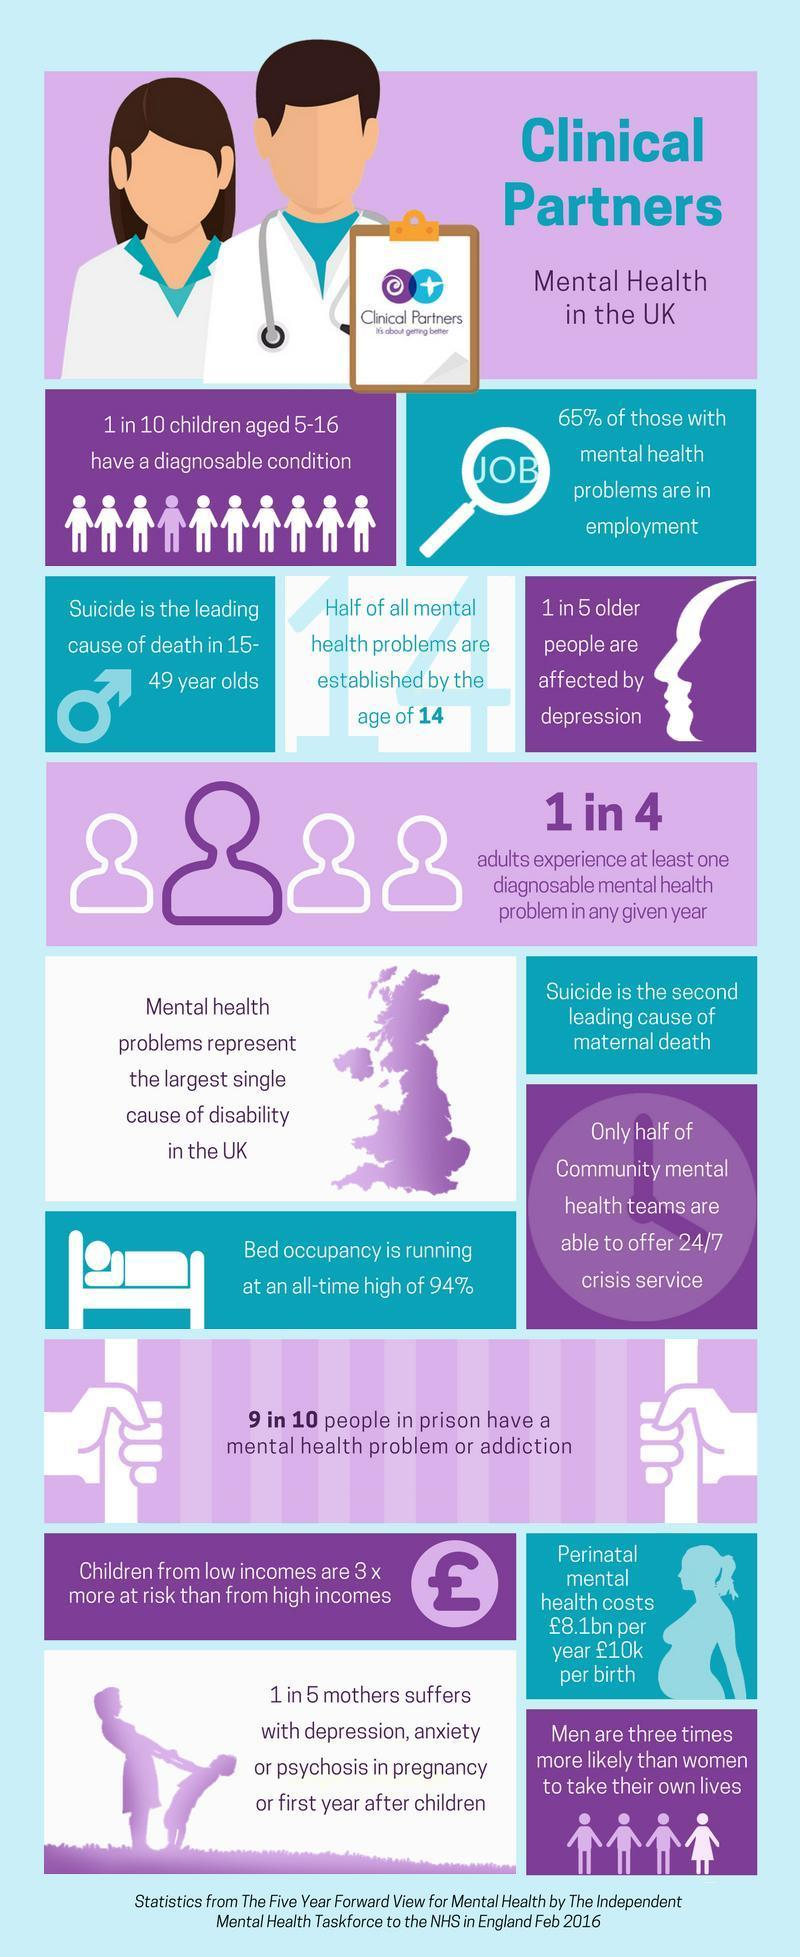What percentage of people in UK employment sector do not have any mental health problems?
Answer the question with a short phrase. 35 What is the major cause of death among people in the age range 15 to 49? Suicide At what age most of the mental health problems are getting started? age of 14 If taken a sample of 5 people, how many people are not going through depression? 4 